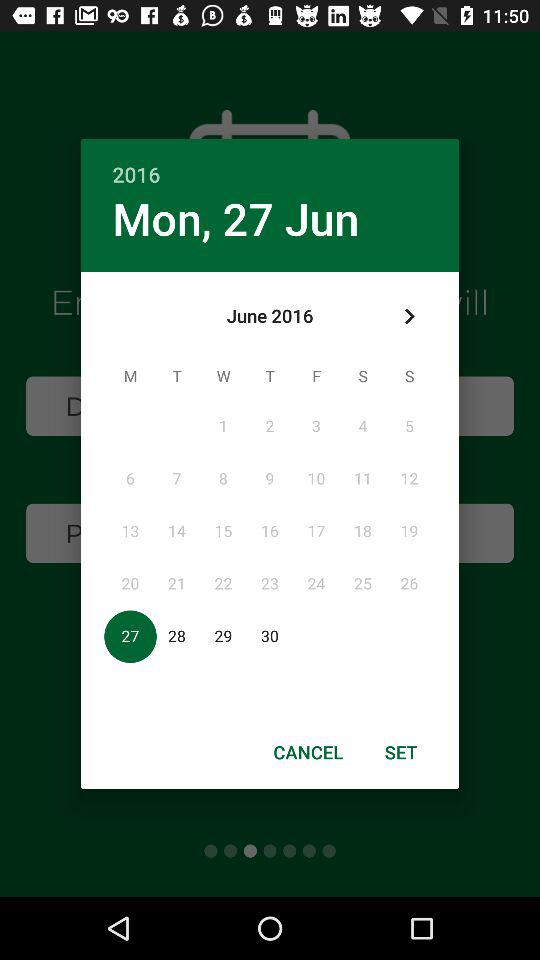What is the selected date? The selected date is Monday, June 27, 2016. 